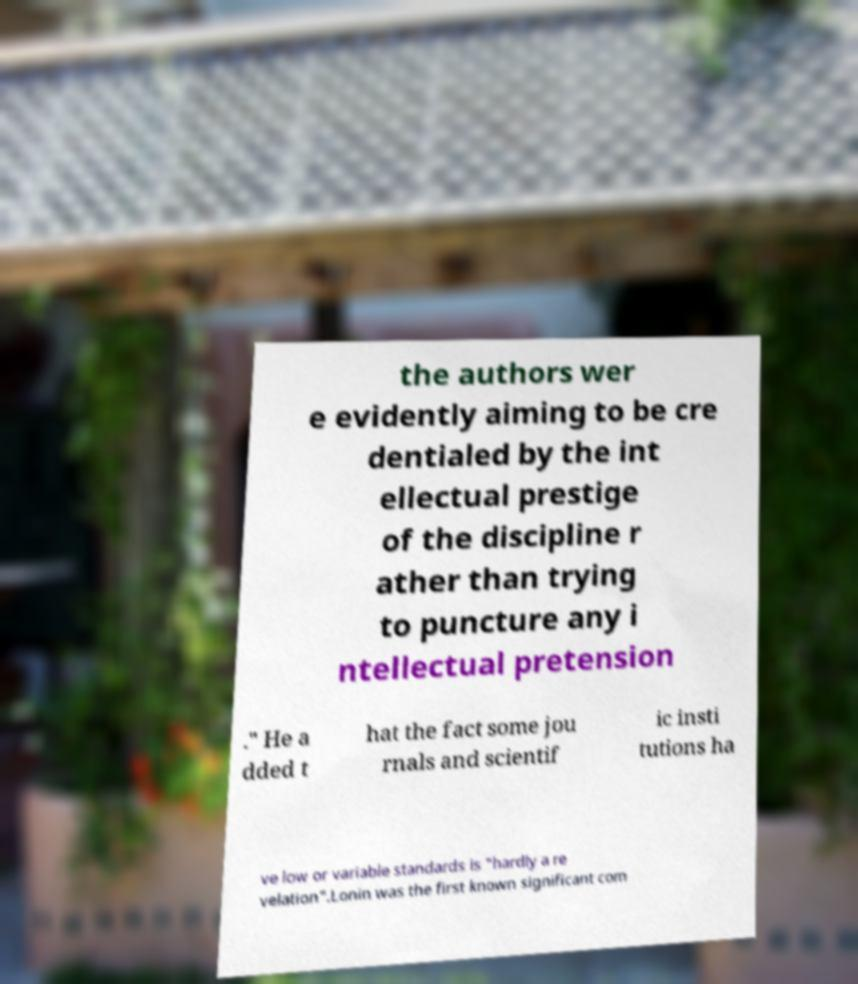Please read and relay the text visible in this image. What does it say? the authors wer e evidently aiming to be cre dentialed by the int ellectual prestige of the discipline r ather than trying to puncture any i ntellectual pretension ." He a dded t hat the fact some jou rnals and scientif ic insti tutions ha ve low or variable standards is "hardly a re velation".Lonin was the first known significant com 